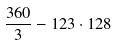<formula> <loc_0><loc_0><loc_500><loc_500>\frac { 3 6 0 } { 3 } - 1 2 3 \cdot 1 2 8</formula> 